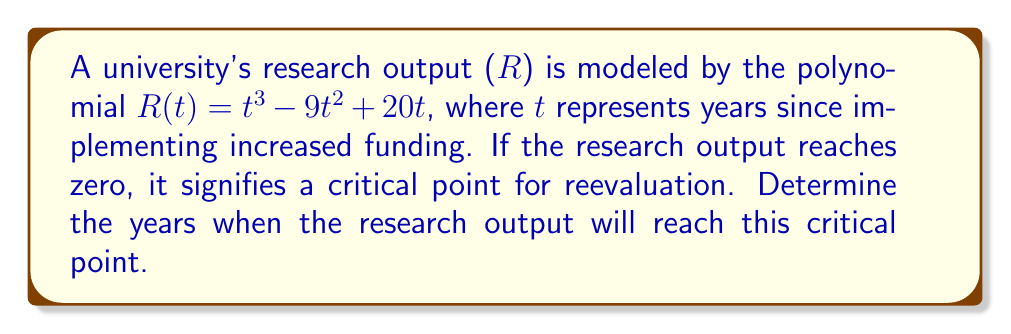Can you solve this math problem? To solve this problem, we need to factor the polynomial $R(t) = t^3 - 9t^2 + 20t$ and find its roots.

Step 1: Factor out the greatest common factor (GCF)
$R(t) = t(t^2 - 9t + 20)$

Step 2: Factor the remaining quadratic expression
$t^2 - 9t + 20$ can be factored as $(t - 5)(t - 4)$

Step 3: Write the fully factored polynomial
$R(t) = t(t - 5)(t - 4)$

Step 4: Determine the roots
The roots of the polynomial are the values of t that make $R(t) = 0$. This occurs when any factor equals zero:

$t = 0$, or $t - 5 = 0$, or $t - 4 = 0$

Solving these equations:
$t = 0$, $t = 5$, or $t = 4$

Therefore, the research output will reach the critical point (zero) at 0, 4, and 5 years after implementing increased funding.
Answer: 0, 4, and 5 years 